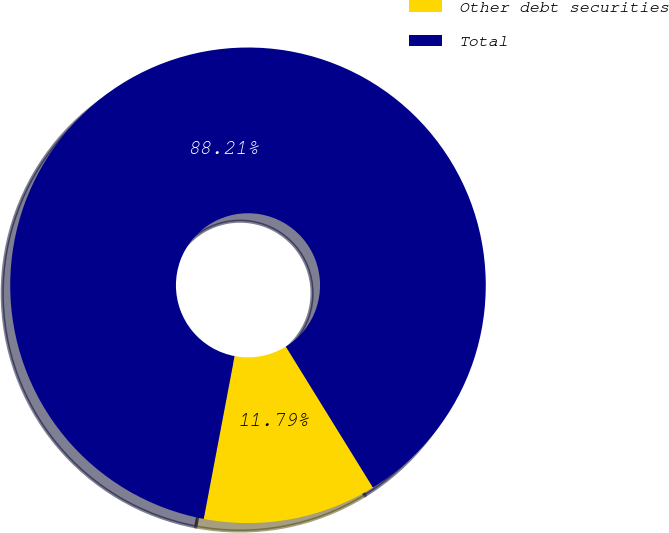<chart> <loc_0><loc_0><loc_500><loc_500><pie_chart><fcel>Other debt securities<fcel>Total<nl><fcel>11.79%<fcel>88.21%<nl></chart> 